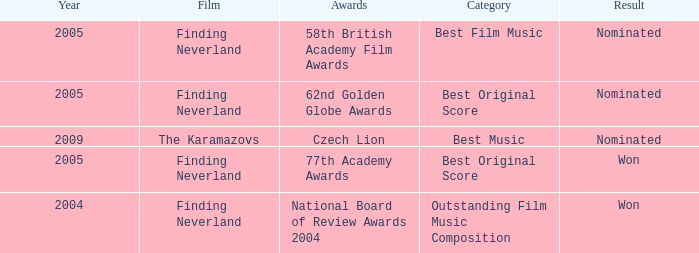What was the result for years prior to 2005? Won. 